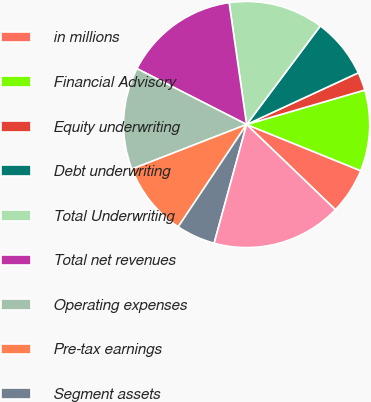<chart> <loc_0><loc_0><loc_500><loc_500><pie_chart><fcel>in millions<fcel>Financial Advisory<fcel>Equity underwriting<fcel>Debt underwriting<fcel>Total Underwriting<fcel>Total net revenues<fcel>Operating expenses<fcel>Pre-tax earnings<fcel>Segment assets<fcel>FICC Client Execution<nl><fcel>6.05%<fcel>10.64%<fcel>2.38%<fcel>7.89%<fcel>12.48%<fcel>15.23%<fcel>13.4%<fcel>9.72%<fcel>5.13%<fcel>17.07%<nl></chart> 